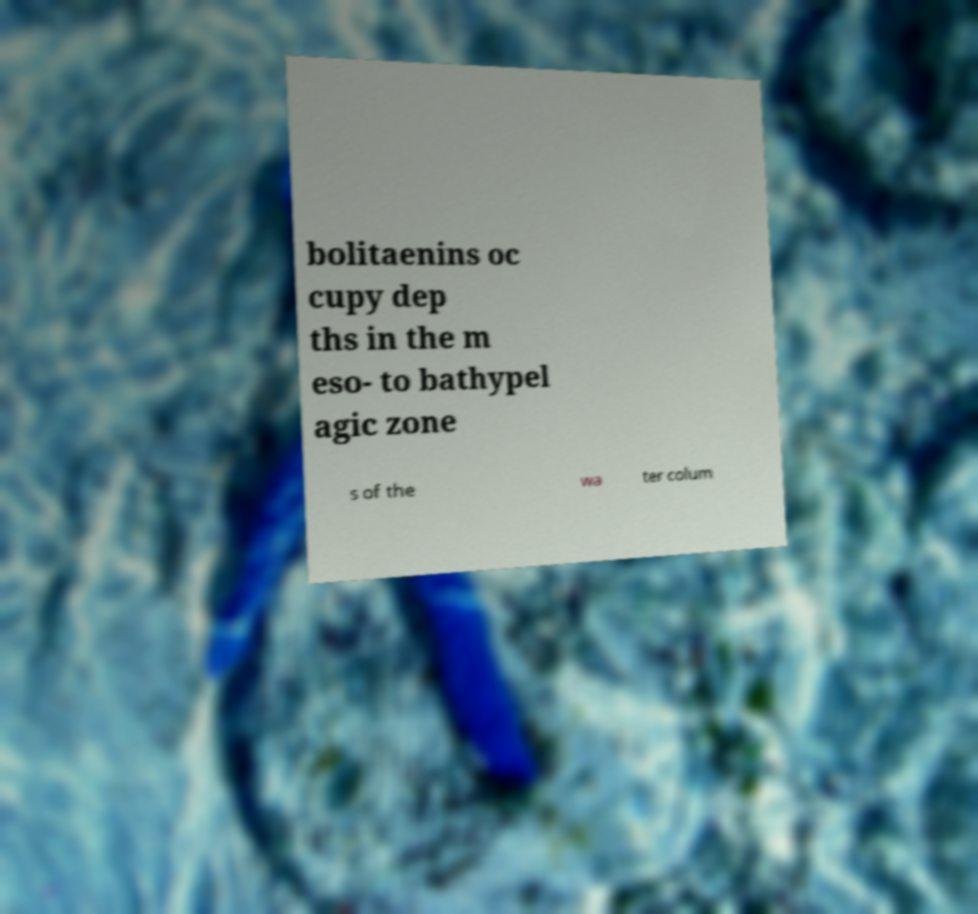What messages or text are displayed in this image? I need them in a readable, typed format. bolitaenins oc cupy dep ths in the m eso- to bathypel agic zone s of the wa ter colum 